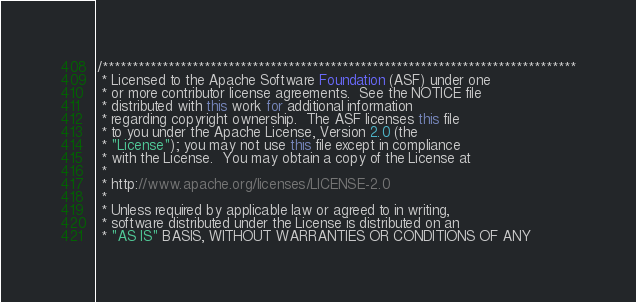Convert code to text. <code><loc_0><loc_0><loc_500><loc_500><_Java_>/*******************************************************************************
 * Licensed to the Apache Software Foundation (ASF) under one
 * or more contributor license agreements.  See the NOTICE file
 * distributed with this work for additional information
 * regarding copyright ownership.  The ASF licenses this file
 * to you under the Apache License, Version 2.0 (the
 * "License"); you may not use this file except in compliance
 * with the License.  You may obtain a copy of the License at
 *
 * http://www.apache.org/licenses/LICENSE-2.0
 *
 * Unless required by applicable law or agreed to in writing,
 * software distributed under the License is distributed on an
 * "AS IS" BASIS, WITHOUT WARRANTIES OR CONDITIONS OF ANY</code> 